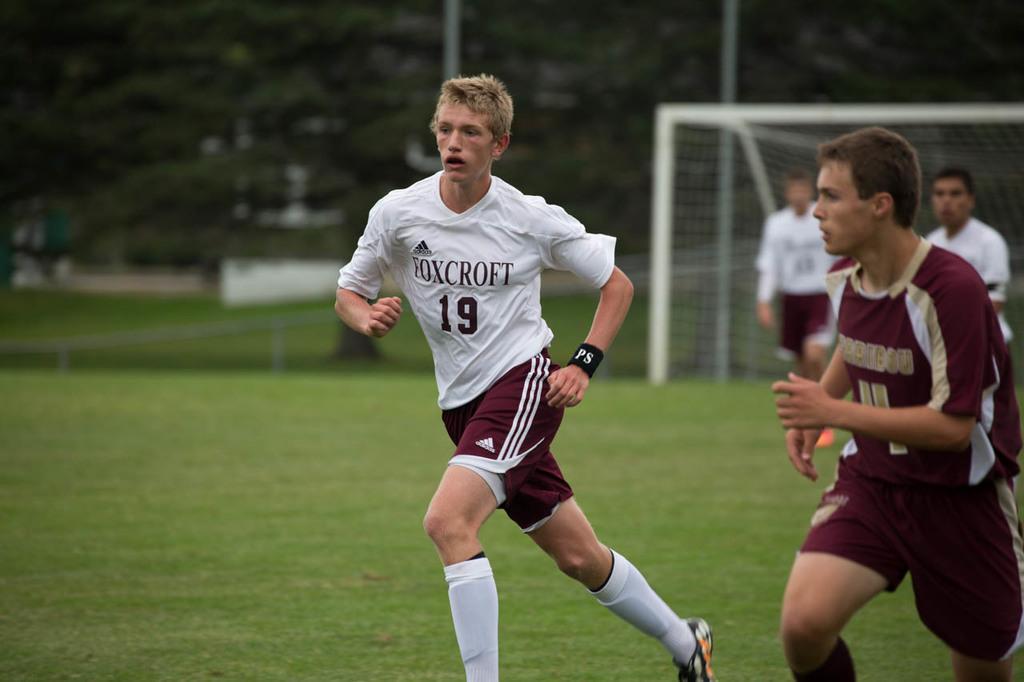What number is the player in white?
Offer a very short reply. 19. What is the name written in the white jersey?
Your answer should be compact. Foxcroft. 